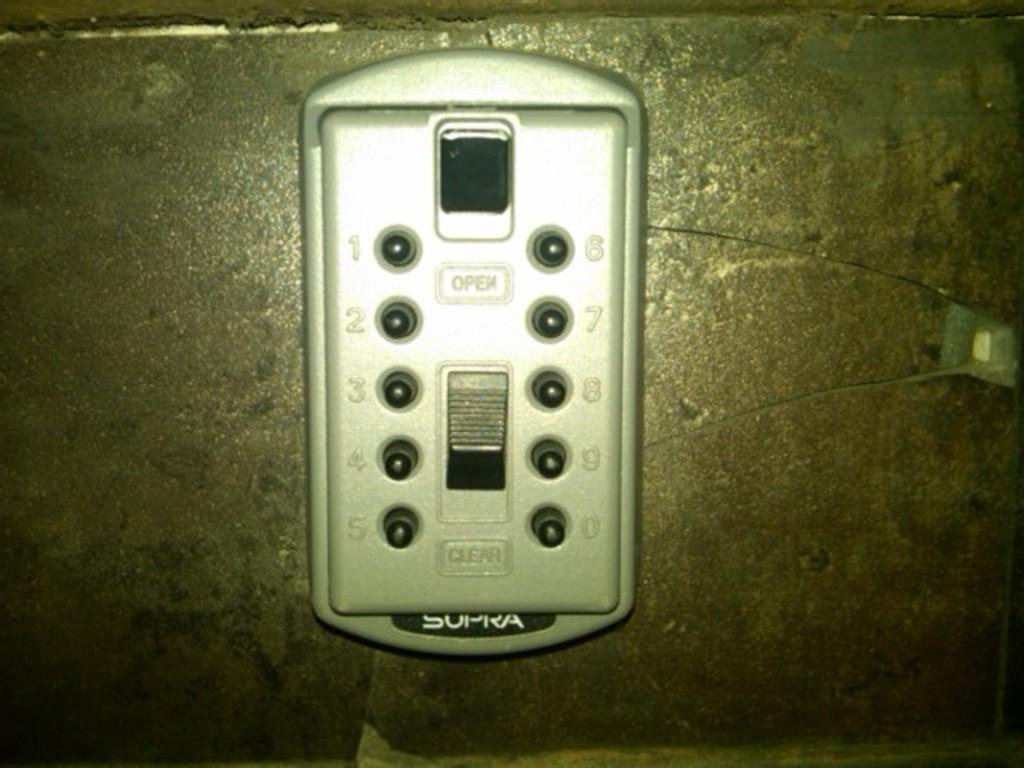Provide a one-sentence caption for the provided image. Some sort of electronic gadget that is white and says "open" on the front. 